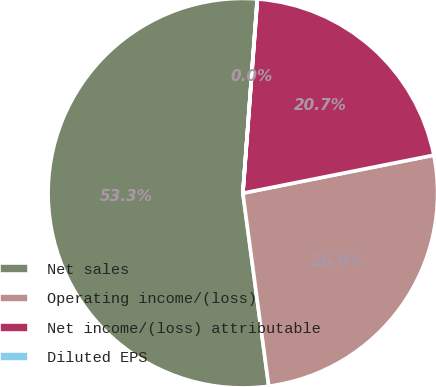<chart> <loc_0><loc_0><loc_500><loc_500><pie_chart><fcel>Net sales<fcel>Operating income/(loss)<fcel>Net income/(loss) attributable<fcel>Diluted EPS<nl><fcel>53.3%<fcel>26.01%<fcel>20.68%<fcel>0.02%<nl></chart> 